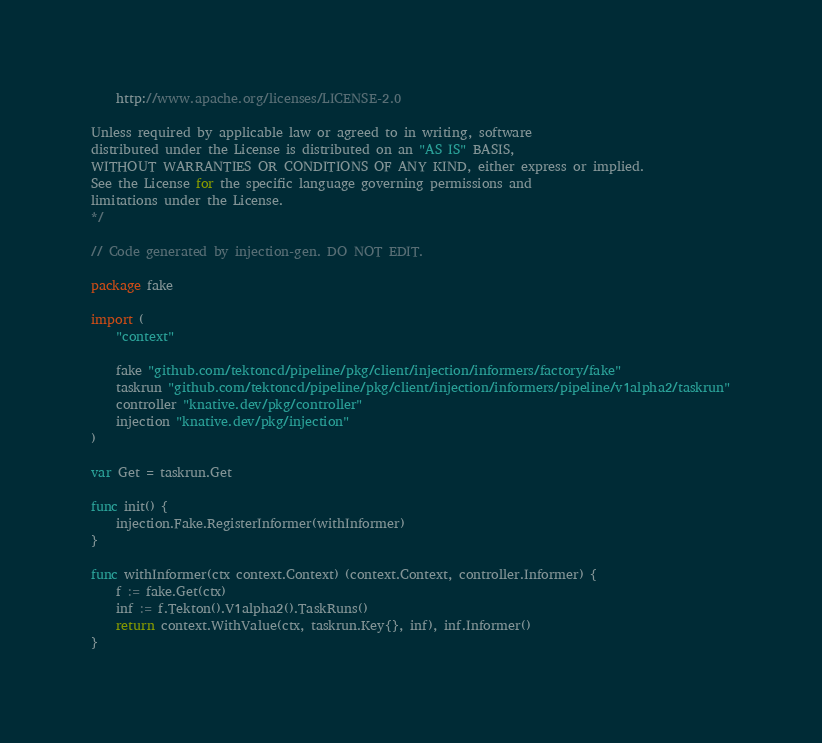<code> <loc_0><loc_0><loc_500><loc_500><_Go_>
    http://www.apache.org/licenses/LICENSE-2.0

Unless required by applicable law or agreed to in writing, software
distributed under the License is distributed on an "AS IS" BASIS,
WITHOUT WARRANTIES OR CONDITIONS OF ANY KIND, either express or implied.
See the License for the specific language governing permissions and
limitations under the License.
*/

// Code generated by injection-gen. DO NOT EDIT.

package fake

import (
	"context"

	fake "github.com/tektoncd/pipeline/pkg/client/injection/informers/factory/fake"
	taskrun "github.com/tektoncd/pipeline/pkg/client/injection/informers/pipeline/v1alpha2/taskrun"
	controller "knative.dev/pkg/controller"
	injection "knative.dev/pkg/injection"
)

var Get = taskrun.Get

func init() {
	injection.Fake.RegisterInformer(withInformer)
}

func withInformer(ctx context.Context) (context.Context, controller.Informer) {
	f := fake.Get(ctx)
	inf := f.Tekton().V1alpha2().TaskRuns()
	return context.WithValue(ctx, taskrun.Key{}, inf), inf.Informer()
}
</code> 